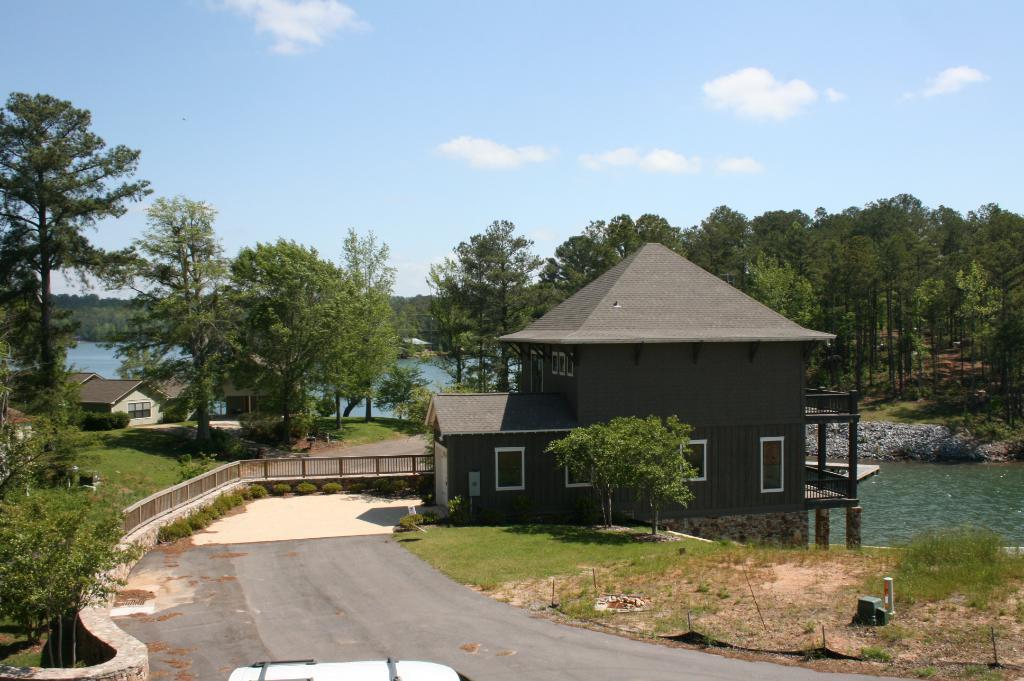Can you describe this image briefly? In this image I can see the house with windows, railing and there is a vehicle on the road. To the right I can see the water and the stones. In the background I can see few more houses, water, many trees, clouds and the sky. 